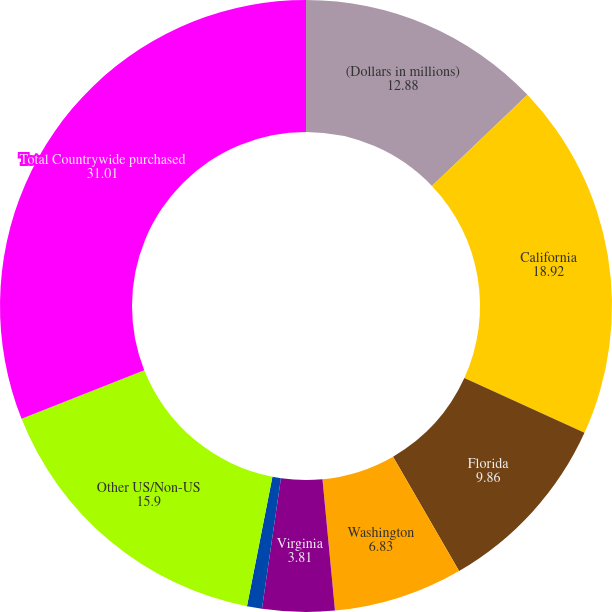Convert chart. <chart><loc_0><loc_0><loc_500><loc_500><pie_chart><fcel>(Dollars in millions)<fcel>California<fcel>Florida<fcel>Washington<fcel>Virginia<fcel>Arizona<fcel>Other US/Non-US<fcel>Total Countrywide purchased<nl><fcel>12.88%<fcel>18.92%<fcel>9.86%<fcel>6.83%<fcel>3.81%<fcel>0.79%<fcel>15.9%<fcel>31.01%<nl></chart> 